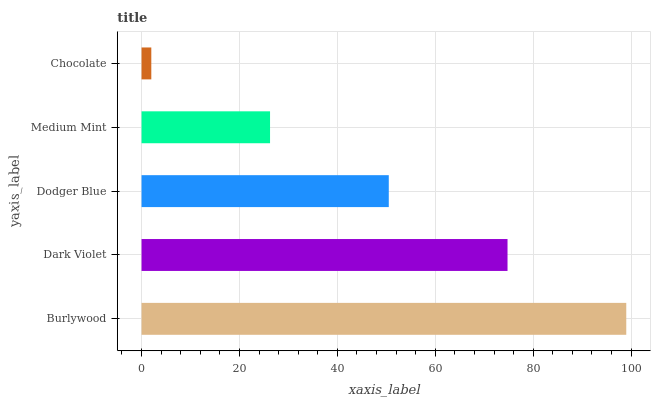Is Chocolate the minimum?
Answer yes or no. Yes. Is Burlywood the maximum?
Answer yes or no. Yes. Is Dark Violet the minimum?
Answer yes or no. No. Is Dark Violet the maximum?
Answer yes or no. No. Is Burlywood greater than Dark Violet?
Answer yes or no. Yes. Is Dark Violet less than Burlywood?
Answer yes or no. Yes. Is Dark Violet greater than Burlywood?
Answer yes or no. No. Is Burlywood less than Dark Violet?
Answer yes or no. No. Is Dodger Blue the high median?
Answer yes or no. Yes. Is Dodger Blue the low median?
Answer yes or no. Yes. Is Burlywood the high median?
Answer yes or no. No. Is Chocolate the low median?
Answer yes or no. No. 